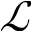<formula> <loc_0><loc_0><loc_500><loc_500>\mathcal { L }</formula> 